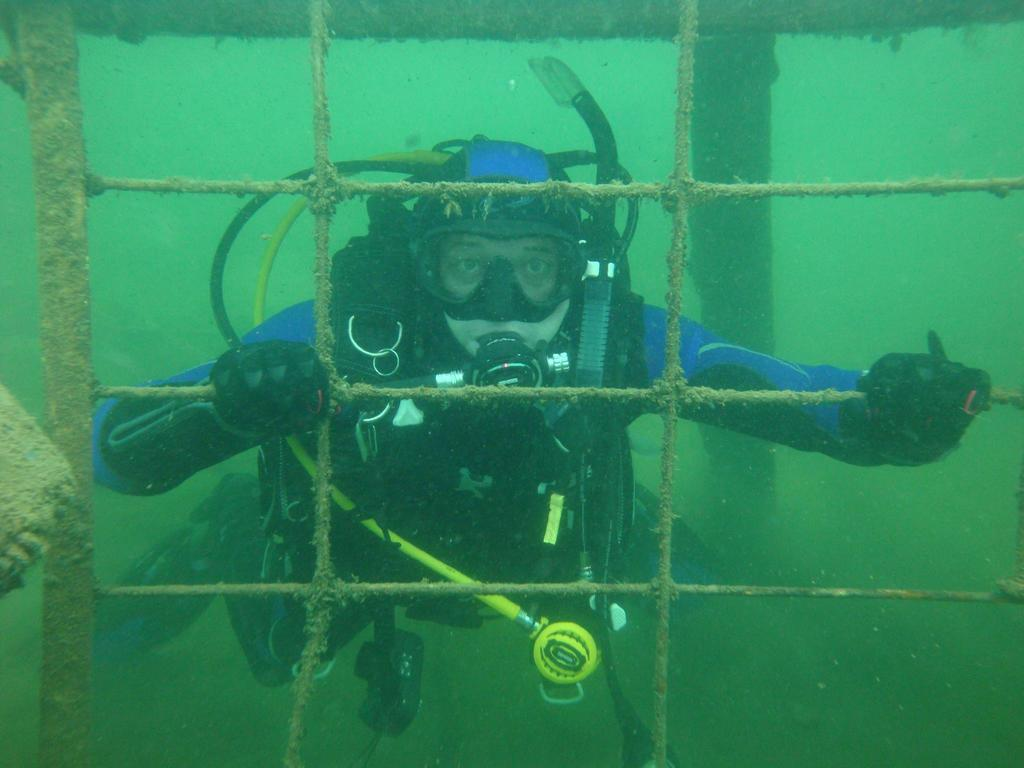Who or what is present in the image? There is a person in the image. What is the person doing in the image? The person is in the water and using oxygen. What object is the person holding in the image? The person is holding an iron grill in the image. What type of arch can be seen in the background of the image? There is no arch present in the image. What facial expression does the person have in the image? The image does not show the person's face, so their facial expression cannot be determined. 